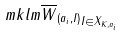Convert formula to latex. <formula><loc_0><loc_0><loc_500><loc_500>\ m k l m { \overline { W } _ { ( a _ { i } , I ) } } _ { I \in X _ { K , a _ { i } } }</formula> 